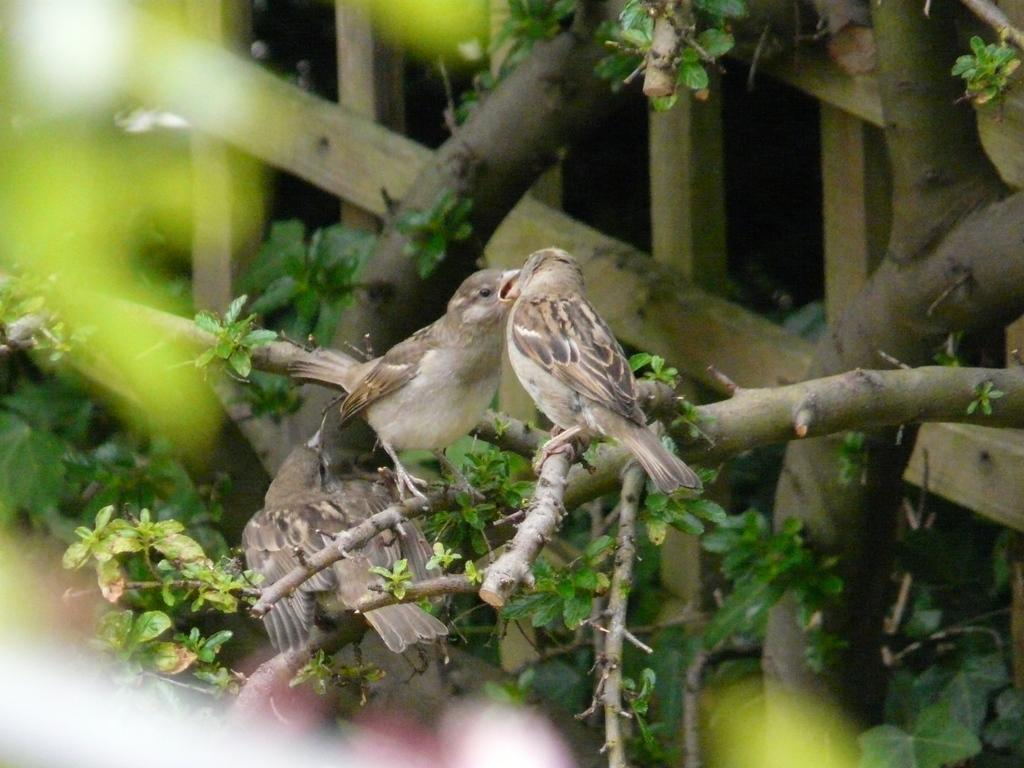How many birds are present in the image? There are two birds in the image. Where are the birds located? The birds are sitting on a tree. Can you describe any other objects or features in the image? There is a wooden object in the background of the image. What type of insurance policy do the birds have in the image? There is no mention of insurance in the image, as it features two birds sitting on a tree and a wooden object in the background. 